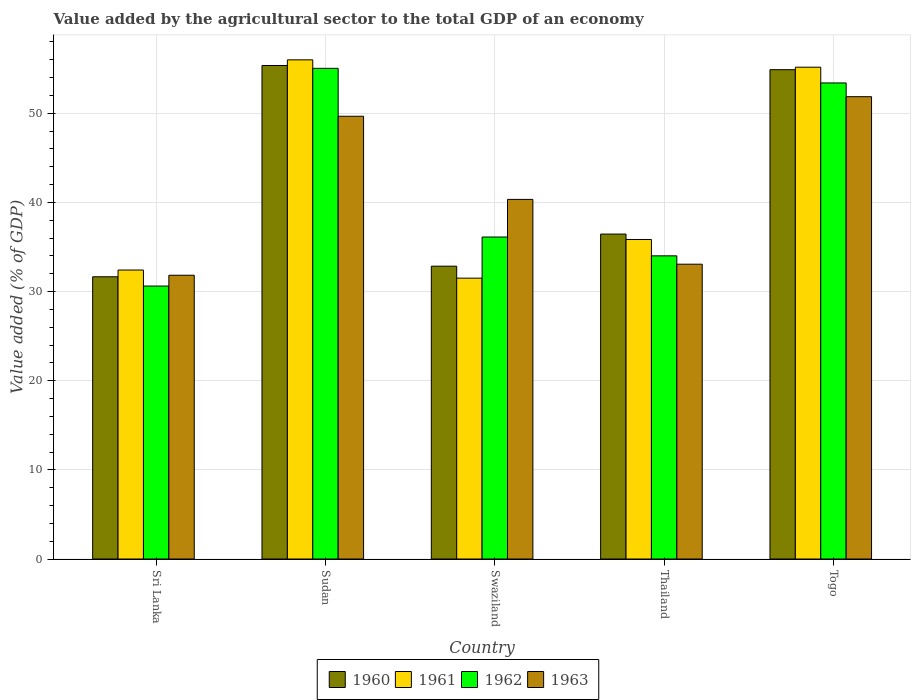How many different coloured bars are there?
Your answer should be compact. 4. Are the number of bars per tick equal to the number of legend labels?
Keep it short and to the point. Yes. How many bars are there on the 5th tick from the left?
Your answer should be compact. 4. What is the label of the 2nd group of bars from the left?
Ensure brevity in your answer.  Sudan. In how many cases, is the number of bars for a given country not equal to the number of legend labels?
Your answer should be very brief. 0. What is the value added by the agricultural sector to the total GDP in 1962 in Sudan?
Your answer should be compact. 55.03. Across all countries, what is the maximum value added by the agricultural sector to the total GDP in 1961?
Give a very brief answer. 55.99. Across all countries, what is the minimum value added by the agricultural sector to the total GDP in 1962?
Offer a terse response. 30.61. In which country was the value added by the agricultural sector to the total GDP in 1960 maximum?
Give a very brief answer. Sudan. In which country was the value added by the agricultural sector to the total GDP in 1960 minimum?
Offer a terse response. Sri Lanka. What is the total value added by the agricultural sector to the total GDP in 1960 in the graph?
Provide a succinct answer. 211.18. What is the difference between the value added by the agricultural sector to the total GDP in 1962 in Swaziland and that in Thailand?
Offer a very short reply. 2.11. What is the difference between the value added by the agricultural sector to the total GDP in 1963 in Swaziland and the value added by the agricultural sector to the total GDP in 1960 in Thailand?
Ensure brevity in your answer.  3.89. What is the average value added by the agricultural sector to the total GDP in 1963 per country?
Provide a succinct answer. 41.35. What is the difference between the value added by the agricultural sector to the total GDP of/in 1961 and value added by the agricultural sector to the total GDP of/in 1963 in Sudan?
Offer a terse response. 6.33. In how many countries, is the value added by the agricultural sector to the total GDP in 1961 greater than 2 %?
Make the answer very short. 5. What is the ratio of the value added by the agricultural sector to the total GDP in 1961 in Swaziland to that in Thailand?
Provide a short and direct response. 0.88. Is the value added by the agricultural sector to the total GDP in 1960 in Thailand less than that in Togo?
Provide a short and direct response. Yes. Is the difference between the value added by the agricultural sector to the total GDP in 1961 in Sri Lanka and Sudan greater than the difference between the value added by the agricultural sector to the total GDP in 1963 in Sri Lanka and Sudan?
Offer a terse response. No. What is the difference between the highest and the second highest value added by the agricultural sector to the total GDP in 1961?
Provide a succinct answer. -19.32. What is the difference between the highest and the lowest value added by the agricultural sector to the total GDP in 1963?
Make the answer very short. 20.03. In how many countries, is the value added by the agricultural sector to the total GDP in 1960 greater than the average value added by the agricultural sector to the total GDP in 1960 taken over all countries?
Your response must be concise. 2. Is the sum of the value added by the agricultural sector to the total GDP in 1961 in Sri Lanka and Swaziland greater than the maximum value added by the agricultural sector to the total GDP in 1960 across all countries?
Your answer should be very brief. Yes. What does the 3rd bar from the right in Sri Lanka represents?
Offer a terse response. 1961. Is it the case that in every country, the sum of the value added by the agricultural sector to the total GDP in 1961 and value added by the agricultural sector to the total GDP in 1960 is greater than the value added by the agricultural sector to the total GDP in 1963?
Keep it short and to the point. Yes. Are all the bars in the graph horizontal?
Give a very brief answer. No. What is the difference between two consecutive major ticks on the Y-axis?
Make the answer very short. 10. Are the values on the major ticks of Y-axis written in scientific E-notation?
Provide a short and direct response. No. Does the graph contain any zero values?
Your answer should be very brief. No. How many legend labels are there?
Offer a terse response. 4. What is the title of the graph?
Give a very brief answer. Value added by the agricultural sector to the total GDP of an economy. Does "1979" appear as one of the legend labels in the graph?
Your response must be concise. No. What is the label or title of the X-axis?
Provide a succinct answer. Country. What is the label or title of the Y-axis?
Your response must be concise. Value added (% of GDP). What is the Value added (% of GDP) in 1960 in Sri Lanka?
Offer a terse response. 31.66. What is the Value added (% of GDP) of 1961 in Sri Lanka?
Offer a very short reply. 32.41. What is the Value added (% of GDP) in 1962 in Sri Lanka?
Give a very brief answer. 30.61. What is the Value added (% of GDP) in 1963 in Sri Lanka?
Give a very brief answer. 31.83. What is the Value added (% of GDP) of 1960 in Sudan?
Provide a succinct answer. 55.35. What is the Value added (% of GDP) in 1961 in Sudan?
Provide a succinct answer. 55.99. What is the Value added (% of GDP) in 1962 in Sudan?
Keep it short and to the point. 55.03. What is the Value added (% of GDP) in 1963 in Sudan?
Offer a terse response. 49.66. What is the Value added (% of GDP) of 1960 in Swaziland?
Your response must be concise. 32.84. What is the Value added (% of GDP) in 1961 in Swaziland?
Keep it short and to the point. 31.5. What is the Value added (% of GDP) of 1962 in Swaziland?
Your response must be concise. 36.11. What is the Value added (% of GDP) of 1963 in Swaziland?
Offer a terse response. 40.33. What is the Value added (% of GDP) in 1960 in Thailand?
Ensure brevity in your answer.  36.44. What is the Value added (% of GDP) in 1961 in Thailand?
Your answer should be compact. 35.84. What is the Value added (% of GDP) of 1962 in Thailand?
Ensure brevity in your answer.  34. What is the Value added (% of GDP) of 1963 in Thailand?
Give a very brief answer. 33.07. What is the Value added (% of GDP) of 1960 in Togo?
Make the answer very short. 54.88. What is the Value added (% of GDP) of 1961 in Togo?
Your answer should be very brief. 55.16. What is the Value added (% of GDP) of 1962 in Togo?
Give a very brief answer. 53.4. What is the Value added (% of GDP) of 1963 in Togo?
Offer a very short reply. 51.85. Across all countries, what is the maximum Value added (% of GDP) in 1960?
Provide a succinct answer. 55.35. Across all countries, what is the maximum Value added (% of GDP) in 1961?
Make the answer very short. 55.99. Across all countries, what is the maximum Value added (% of GDP) in 1962?
Keep it short and to the point. 55.03. Across all countries, what is the maximum Value added (% of GDP) of 1963?
Offer a very short reply. 51.85. Across all countries, what is the minimum Value added (% of GDP) in 1960?
Offer a very short reply. 31.66. Across all countries, what is the minimum Value added (% of GDP) in 1961?
Your response must be concise. 31.5. Across all countries, what is the minimum Value added (% of GDP) in 1962?
Offer a very short reply. 30.61. Across all countries, what is the minimum Value added (% of GDP) of 1963?
Give a very brief answer. 31.83. What is the total Value added (% of GDP) in 1960 in the graph?
Offer a terse response. 211.18. What is the total Value added (% of GDP) of 1961 in the graph?
Your answer should be very brief. 210.9. What is the total Value added (% of GDP) of 1962 in the graph?
Your response must be concise. 209.16. What is the total Value added (% of GDP) of 1963 in the graph?
Ensure brevity in your answer.  206.74. What is the difference between the Value added (% of GDP) in 1960 in Sri Lanka and that in Sudan?
Your answer should be very brief. -23.7. What is the difference between the Value added (% of GDP) of 1961 in Sri Lanka and that in Sudan?
Give a very brief answer. -23.58. What is the difference between the Value added (% of GDP) of 1962 in Sri Lanka and that in Sudan?
Keep it short and to the point. -24.42. What is the difference between the Value added (% of GDP) in 1963 in Sri Lanka and that in Sudan?
Your answer should be very brief. -17.83. What is the difference between the Value added (% of GDP) in 1960 in Sri Lanka and that in Swaziland?
Offer a terse response. -1.19. What is the difference between the Value added (% of GDP) of 1961 in Sri Lanka and that in Swaziland?
Your answer should be very brief. 0.91. What is the difference between the Value added (% of GDP) in 1962 in Sri Lanka and that in Swaziland?
Offer a terse response. -5.5. What is the difference between the Value added (% of GDP) of 1963 in Sri Lanka and that in Swaziland?
Your answer should be very brief. -8.51. What is the difference between the Value added (% of GDP) in 1960 in Sri Lanka and that in Thailand?
Your response must be concise. -4.79. What is the difference between the Value added (% of GDP) in 1961 in Sri Lanka and that in Thailand?
Provide a short and direct response. -3.43. What is the difference between the Value added (% of GDP) in 1962 in Sri Lanka and that in Thailand?
Your answer should be very brief. -3.39. What is the difference between the Value added (% of GDP) in 1963 in Sri Lanka and that in Thailand?
Ensure brevity in your answer.  -1.24. What is the difference between the Value added (% of GDP) in 1960 in Sri Lanka and that in Togo?
Offer a very short reply. -23.23. What is the difference between the Value added (% of GDP) in 1961 in Sri Lanka and that in Togo?
Your answer should be very brief. -22.75. What is the difference between the Value added (% of GDP) in 1962 in Sri Lanka and that in Togo?
Ensure brevity in your answer.  -22.78. What is the difference between the Value added (% of GDP) in 1963 in Sri Lanka and that in Togo?
Provide a short and direct response. -20.03. What is the difference between the Value added (% of GDP) in 1960 in Sudan and that in Swaziland?
Keep it short and to the point. 22.51. What is the difference between the Value added (% of GDP) of 1961 in Sudan and that in Swaziland?
Ensure brevity in your answer.  24.49. What is the difference between the Value added (% of GDP) of 1962 in Sudan and that in Swaziland?
Offer a very short reply. 18.92. What is the difference between the Value added (% of GDP) of 1963 in Sudan and that in Swaziland?
Ensure brevity in your answer.  9.32. What is the difference between the Value added (% of GDP) of 1960 in Sudan and that in Thailand?
Your answer should be very brief. 18.91. What is the difference between the Value added (% of GDP) in 1961 in Sudan and that in Thailand?
Keep it short and to the point. 20.15. What is the difference between the Value added (% of GDP) in 1962 in Sudan and that in Thailand?
Keep it short and to the point. 21.03. What is the difference between the Value added (% of GDP) in 1963 in Sudan and that in Thailand?
Your answer should be very brief. 16.59. What is the difference between the Value added (% of GDP) in 1960 in Sudan and that in Togo?
Provide a succinct answer. 0.47. What is the difference between the Value added (% of GDP) of 1961 in Sudan and that in Togo?
Offer a terse response. 0.83. What is the difference between the Value added (% of GDP) in 1962 in Sudan and that in Togo?
Offer a very short reply. 1.64. What is the difference between the Value added (% of GDP) in 1963 in Sudan and that in Togo?
Keep it short and to the point. -2.19. What is the difference between the Value added (% of GDP) of 1960 in Swaziland and that in Thailand?
Provide a short and direct response. -3.6. What is the difference between the Value added (% of GDP) in 1961 in Swaziland and that in Thailand?
Your answer should be very brief. -4.34. What is the difference between the Value added (% of GDP) of 1962 in Swaziland and that in Thailand?
Keep it short and to the point. 2.11. What is the difference between the Value added (% of GDP) in 1963 in Swaziland and that in Thailand?
Give a very brief answer. 7.27. What is the difference between the Value added (% of GDP) of 1960 in Swaziland and that in Togo?
Keep it short and to the point. -22.04. What is the difference between the Value added (% of GDP) of 1961 in Swaziland and that in Togo?
Keep it short and to the point. -23.66. What is the difference between the Value added (% of GDP) of 1962 in Swaziland and that in Togo?
Your response must be concise. -17.28. What is the difference between the Value added (% of GDP) in 1963 in Swaziland and that in Togo?
Give a very brief answer. -11.52. What is the difference between the Value added (% of GDP) of 1960 in Thailand and that in Togo?
Provide a short and direct response. -18.44. What is the difference between the Value added (% of GDP) in 1961 in Thailand and that in Togo?
Provide a succinct answer. -19.32. What is the difference between the Value added (% of GDP) of 1962 in Thailand and that in Togo?
Your answer should be very brief. -19.39. What is the difference between the Value added (% of GDP) in 1963 in Thailand and that in Togo?
Provide a succinct answer. -18.79. What is the difference between the Value added (% of GDP) of 1960 in Sri Lanka and the Value added (% of GDP) of 1961 in Sudan?
Keep it short and to the point. -24.33. What is the difference between the Value added (% of GDP) of 1960 in Sri Lanka and the Value added (% of GDP) of 1962 in Sudan?
Offer a terse response. -23.38. What is the difference between the Value added (% of GDP) in 1960 in Sri Lanka and the Value added (% of GDP) in 1963 in Sudan?
Make the answer very short. -18. What is the difference between the Value added (% of GDP) in 1961 in Sri Lanka and the Value added (% of GDP) in 1962 in Sudan?
Give a very brief answer. -22.62. What is the difference between the Value added (% of GDP) of 1961 in Sri Lanka and the Value added (% of GDP) of 1963 in Sudan?
Your response must be concise. -17.25. What is the difference between the Value added (% of GDP) in 1962 in Sri Lanka and the Value added (% of GDP) in 1963 in Sudan?
Give a very brief answer. -19.04. What is the difference between the Value added (% of GDP) of 1960 in Sri Lanka and the Value added (% of GDP) of 1961 in Swaziland?
Your answer should be compact. 0.16. What is the difference between the Value added (% of GDP) in 1960 in Sri Lanka and the Value added (% of GDP) in 1962 in Swaziland?
Offer a very short reply. -4.46. What is the difference between the Value added (% of GDP) of 1960 in Sri Lanka and the Value added (% of GDP) of 1963 in Swaziland?
Make the answer very short. -8.68. What is the difference between the Value added (% of GDP) of 1961 in Sri Lanka and the Value added (% of GDP) of 1962 in Swaziland?
Offer a very short reply. -3.7. What is the difference between the Value added (% of GDP) of 1961 in Sri Lanka and the Value added (% of GDP) of 1963 in Swaziland?
Keep it short and to the point. -7.92. What is the difference between the Value added (% of GDP) of 1962 in Sri Lanka and the Value added (% of GDP) of 1963 in Swaziland?
Offer a very short reply. -9.72. What is the difference between the Value added (% of GDP) in 1960 in Sri Lanka and the Value added (% of GDP) in 1961 in Thailand?
Give a very brief answer. -4.18. What is the difference between the Value added (% of GDP) in 1960 in Sri Lanka and the Value added (% of GDP) in 1962 in Thailand?
Offer a terse response. -2.35. What is the difference between the Value added (% of GDP) in 1960 in Sri Lanka and the Value added (% of GDP) in 1963 in Thailand?
Provide a short and direct response. -1.41. What is the difference between the Value added (% of GDP) in 1961 in Sri Lanka and the Value added (% of GDP) in 1962 in Thailand?
Offer a terse response. -1.59. What is the difference between the Value added (% of GDP) of 1961 in Sri Lanka and the Value added (% of GDP) of 1963 in Thailand?
Provide a succinct answer. -0.65. What is the difference between the Value added (% of GDP) of 1962 in Sri Lanka and the Value added (% of GDP) of 1963 in Thailand?
Ensure brevity in your answer.  -2.45. What is the difference between the Value added (% of GDP) of 1960 in Sri Lanka and the Value added (% of GDP) of 1961 in Togo?
Provide a short and direct response. -23.51. What is the difference between the Value added (% of GDP) of 1960 in Sri Lanka and the Value added (% of GDP) of 1962 in Togo?
Your answer should be compact. -21.74. What is the difference between the Value added (% of GDP) of 1960 in Sri Lanka and the Value added (% of GDP) of 1963 in Togo?
Your answer should be very brief. -20.2. What is the difference between the Value added (% of GDP) in 1961 in Sri Lanka and the Value added (% of GDP) in 1962 in Togo?
Give a very brief answer. -20.98. What is the difference between the Value added (% of GDP) in 1961 in Sri Lanka and the Value added (% of GDP) in 1963 in Togo?
Ensure brevity in your answer.  -19.44. What is the difference between the Value added (% of GDP) in 1962 in Sri Lanka and the Value added (% of GDP) in 1963 in Togo?
Your response must be concise. -21.24. What is the difference between the Value added (% of GDP) in 1960 in Sudan and the Value added (% of GDP) in 1961 in Swaziland?
Ensure brevity in your answer.  23.85. What is the difference between the Value added (% of GDP) in 1960 in Sudan and the Value added (% of GDP) in 1962 in Swaziland?
Your response must be concise. 19.24. What is the difference between the Value added (% of GDP) of 1960 in Sudan and the Value added (% of GDP) of 1963 in Swaziland?
Provide a succinct answer. 15.02. What is the difference between the Value added (% of GDP) in 1961 in Sudan and the Value added (% of GDP) in 1962 in Swaziland?
Offer a terse response. 19.87. What is the difference between the Value added (% of GDP) in 1961 in Sudan and the Value added (% of GDP) in 1963 in Swaziland?
Give a very brief answer. 15.65. What is the difference between the Value added (% of GDP) in 1962 in Sudan and the Value added (% of GDP) in 1963 in Swaziland?
Your response must be concise. 14.7. What is the difference between the Value added (% of GDP) in 1960 in Sudan and the Value added (% of GDP) in 1961 in Thailand?
Your response must be concise. 19.51. What is the difference between the Value added (% of GDP) in 1960 in Sudan and the Value added (% of GDP) in 1962 in Thailand?
Your answer should be compact. 21.35. What is the difference between the Value added (% of GDP) in 1960 in Sudan and the Value added (% of GDP) in 1963 in Thailand?
Provide a short and direct response. 22.29. What is the difference between the Value added (% of GDP) of 1961 in Sudan and the Value added (% of GDP) of 1962 in Thailand?
Ensure brevity in your answer.  21.98. What is the difference between the Value added (% of GDP) in 1961 in Sudan and the Value added (% of GDP) in 1963 in Thailand?
Offer a terse response. 22.92. What is the difference between the Value added (% of GDP) in 1962 in Sudan and the Value added (% of GDP) in 1963 in Thailand?
Make the answer very short. 21.97. What is the difference between the Value added (% of GDP) in 1960 in Sudan and the Value added (% of GDP) in 1961 in Togo?
Give a very brief answer. 0.19. What is the difference between the Value added (% of GDP) of 1960 in Sudan and the Value added (% of GDP) of 1962 in Togo?
Make the answer very short. 1.96. What is the difference between the Value added (% of GDP) of 1960 in Sudan and the Value added (% of GDP) of 1963 in Togo?
Keep it short and to the point. 3.5. What is the difference between the Value added (% of GDP) of 1961 in Sudan and the Value added (% of GDP) of 1962 in Togo?
Your response must be concise. 2.59. What is the difference between the Value added (% of GDP) in 1961 in Sudan and the Value added (% of GDP) in 1963 in Togo?
Keep it short and to the point. 4.13. What is the difference between the Value added (% of GDP) of 1962 in Sudan and the Value added (% of GDP) of 1963 in Togo?
Your answer should be very brief. 3.18. What is the difference between the Value added (% of GDP) of 1960 in Swaziland and the Value added (% of GDP) of 1961 in Thailand?
Keep it short and to the point. -2.99. What is the difference between the Value added (% of GDP) in 1960 in Swaziland and the Value added (% of GDP) in 1962 in Thailand?
Offer a terse response. -1.16. What is the difference between the Value added (% of GDP) in 1960 in Swaziland and the Value added (% of GDP) in 1963 in Thailand?
Offer a terse response. -0.22. What is the difference between the Value added (% of GDP) of 1961 in Swaziland and the Value added (% of GDP) of 1962 in Thailand?
Your answer should be very brief. -2.5. What is the difference between the Value added (% of GDP) in 1961 in Swaziland and the Value added (% of GDP) in 1963 in Thailand?
Keep it short and to the point. -1.57. What is the difference between the Value added (% of GDP) in 1962 in Swaziland and the Value added (% of GDP) in 1963 in Thailand?
Your answer should be compact. 3.05. What is the difference between the Value added (% of GDP) in 1960 in Swaziland and the Value added (% of GDP) in 1961 in Togo?
Offer a very short reply. -22.32. What is the difference between the Value added (% of GDP) in 1960 in Swaziland and the Value added (% of GDP) in 1962 in Togo?
Offer a terse response. -20.55. What is the difference between the Value added (% of GDP) in 1960 in Swaziland and the Value added (% of GDP) in 1963 in Togo?
Offer a terse response. -19.01. What is the difference between the Value added (% of GDP) of 1961 in Swaziland and the Value added (% of GDP) of 1962 in Togo?
Your answer should be compact. -21.9. What is the difference between the Value added (% of GDP) in 1961 in Swaziland and the Value added (% of GDP) in 1963 in Togo?
Make the answer very short. -20.35. What is the difference between the Value added (% of GDP) in 1962 in Swaziland and the Value added (% of GDP) in 1963 in Togo?
Offer a terse response. -15.74. What is the difference between the Value added (% of GDP) in 1960 in Thailand and the Value added (% of GDP) in 1961 in Togo?
Provide a succinct answer. -18.72. What is the difference between the Value added (% of GDP) of 1960 in Thailand and the Value added (% of GDP) of 1962 in Togo?
Your response must be concise. -16.95. What is the difference between the Value added (% of GDP) in 1960 in Thailand and the Value added (% of GDP) in 1963 in Togo?
Make the answer very short. -15.41. What is the difference between the Value added (% of GDP) in 1961 in Thailand and the Value added (% of GDP) in 1962 in Togo?
Your answer should be compact. -17.56. What is the difference between the Value added (% of GDP) of 1961 in Thailand and the Value added (% of GDP) of 1963 in Togo?
Your response must be concise. -16.01. What is the difference between the Value added (% of GDP) of 1962 in Thailand and the Value added (% of GDP) of 1963 in Togo?
Your response must be concise. -17.85. What is the average Value added (% of GDP) of 1960 per country?
Give a very brief answer. 42.24. What is the average Value added (% of GDP) in 1961 per country?
Give a very brief answer. 42.18. What is the average Value added (% of GDP) of 1962 per country?
Make the answer very short. 41.83. What is the average Value added (% of GDP) of 1963 per country?
Your answer should be compact. 41.35. What is the difference between the Value added (% of GDP) in 1960 and Value added (% of GDP) in 1961 in Sri Lanka?
Make the answer very short. -0.76. What is the difference between the Value added (% of GDP) of 1960 and Value added (% of GDP) of 1962 in Sri Lanka?
Your answer should be compact. 1.04. What is the difference between the Value added (% of GDP) of 1960 and Value added (% of GDP) of 1963 in Sri Lanka?
Make the answer very short. -0.17. What is the difference between the Value added (% of GDP) in 1961 and Value added (% of GDP) in 1962 in Sri Lanka?
Your answer should be compact. 1.8. What is the difference between the Value added (% of GDP) in 1961 and Value added (% of GDP) in 1963 in Sri Lanka?
Provide a short and direct response. 0.59. What is the difference between the Value added (% of GDP) in 1962 and Value added (% of GDP) in 1963 in Sri Lanka?
Ensure brevity in your answer.  -1.21. What is the difference between the Value added (% of GDP) of 1960 and Value added (% of GDP) of 1961 in Sudan?
Give a very brief answer. -0.64. What is the difference between the Value added (% of GDP) of 1960 and Value added (% of GDP) of 1962 in Sudan?
Provide a succinct answer. 0.32. What is the difference between the Value added (% of GDP) in 1960 and Value added (% of GDP) in 1963 in Sudan?
Provide a succinct answer. 5.69. What is the difference between the Value added (% of GDP) of 1961 and Value added (% of GDP) of 1962 in Sudan?
Your response must be concise. 0.95. What is the difference between the Value added (% of GDP) of 1961 and Value added (% of GDP) of 1963 in Sudan?
Your answer should be compact. 6.33. What is the difference between the Value added (% of GDP) in 1962 and Value added (% of GDP) in 1963 in Sudan?
Keep it short and to the point. 5.37. What is the difference between the Value added (% of GDP) in 1960 and Value added (% of GDP) in 1961 in Swaziland?
Keep it short and to the point. 1.35. What is the difference between the Value added (% of GDP) of 1960 and Value added (% of GDP) of 1962 in Swaziland?
Give a very brief answer. -3.27. What is the difference between the Value added (% of GDP) in 1960 and Value added (% of GDP) in 1963 in Swaziland?
Your answer should be very brief. -7.49. What is the difference between the Value added (% of GDP) of 1961 and Value added (% of GDP) of 1962 in Swaziland?
Your answer should be compact. -4.61. What is the difference between the Value added (% of GDP) in 1961 and Value added (% of GDP) in 1963 in Swaziland?
Provide a short and direct response. -8.83. What is the difference between the Value added (% of GDP) in 1962 and Value added (% of GDP) in 1963 in Swaziland?
Your answer should be compact. -4.22. What is the difference between the Value added (% of GDP) of 1960 and Value added (% of GDP) of 1961 in Thailand?
Make the answer very short. 0.61. What is the difference between the Value added (% of GDP) of 1960 and Value added (% of GDP) of 1962 in Thailand?
Give a very brief answer. 2.44. What is the difference between the Value added (% of GDP) in 1960 and Value added (% of GDP) in 1963 in Thailand?
Provide a succinct answer. 3.38. What is the difference between the Value added (% of GDP) of 1961 and Value added (% of GDP) of 1962 in Thailand?
Provide a short and direct response. 1.84. What is the difference between the Value added (% of GDP) of 1961 and Value added (% of GDP) of 1963 in Thailand?
Ensure brevity in your answer.  2.77. What is the difference between the Value added (% of GDP) of 1962 and Value added (% of GDP) of 1963 in Thailand?
Your answer should be compact. 0.94. What is the difference between the Value added (% of GDP) of 1960 and Value added (% of GDP) of 1961 in Togo?
Your response must be concise. -0.28. What is the difference between the Value added (% of GDP) of 1960 and Value added (% of GDP) of 1962 in Togo?
Your response must be concise. 1.49. What is the difference between the Value added (% of GDP) in 1960 and Value added (% of GDP) in 1963 in Togo?
Offer a very short reply. 3.03. What is the difference between the Value added (% of GDP) of 1961 and Value added (% of GDP) of 1962 in Togo?
Keep it short and to the point. 1.77. What is the difference between the Value added (% of GDP) of 1961 and Value added (% of GDP) of 1963 in Togo?
Your answer should be compact. 3.31. What is the difference between the Value added (% of GDP) in 1962 and Value added (% of GDP) in 1963 in Togo?
Offer a terse response. 1.54. What is the ratio of the Value added (% of GDP) in 1960 in Sri Lanka to that in Sudan?
Keep it short and to the point. 0.57. What is the ratio of the Value added (% of GDP) in 1961 in Sri Lanka to that in Sudan?
Offer a very short reply. 0.58. What is the ratio of the Value added (% of GDP) of 1962 in Sri Lanka to that in Sudan?
Provide a succinct answer. 0.56. What is the ratio of the Value added (% of GDP) of 1963 in Sri Lanka to that in Sudan?
Your response must be concise. 0.64. What is the ratio of the Value added (% of GDP) in 1960 in Sri Lanka to that in Swaziland?
Give a very brief answer. 0.96. What is the ratio of the Value added (% of GDP) in 1961 in Sri Lanka to that in Swaziland?
Your response must be concise. 1.03. What is the ratio of the Value added (% of GDP) in 1962 in Sri Lanka to that in Swaziland?
Offer a very short reply. 0.85. What is the ratio of the Value added (% of GDP) of 1963 in Sri Lanka to that in Swaziland?
Your answer should be compact. 0.79. What is the ratio of the Value added (% of GDP) of 1960 in Sri Lanka to that in Thailand?
Give a very brief answer. 0.87. What is the ratio of the Value added (% of GDP) in 1961 in Sri Lanka to that in Thailand?
Your response must be concise. 0.9. What is the ratio of the Value added (% of GDP) in 1962 in Sri Lanka to that in Thailand?
Your response must be concise. 0.9. What is the ratio of the Value added (% of GDP) of 1963 in Sri Lanka to that in Thailand?
Make the answer very short. 0.96. What is the ratio of the Value added (% of GDP) of 1960 in Sri Lanka to that in Togo?
Keep it short and to the point. 0.58. What is the ratio of the Value added (% of GDP) of 1961 in Sri Lanka to that in Togo?
Offer a very short reply. 0.59. What is the ratio of the Value added (% of GDP) of 1962 in Sri Lanka to that in Togo?
Your answer should be compact. 0.57. What is the ratio of the Value added (% of GDP) in 1963 in Sri Lanka to that in Togo?
Provide a succinct answer. 0.61. What is the ratio of the Value added (% of GDP) in 1960 in Sudan to that in Swaziland?
Provide a short and direct response. 1.69. What is the ratio of the Value added (% of GDP) in 1961 in Sudan to that in Swaziland?
Give a very brief answer. 1.78. What is the ratio of the Value added (% of GDP) in 1962 in Sudan to that in Swaziland?
Your answer should be compact. 1.52. What is the ratio of the Value added (% of GDP) of 1963 in Sudan to that in Swaziland?
Give a very brief answer. 1.23. What is the ratio of the Value added (% of GDP) in 1960 in Sudan to that in Thailand?
Give a very brief answer. 1.52. What is the ratio of the Value added (% of GDP) in 1961 in Sudan to that in Thailand?
Make the answer very short. 1.56. What is the ratio of the Value added (% of GDP) in 1962 in Sudan to that in Thailand?
Make the answer very short. 1.62. What is the ratio of the Value added (% of GDP) of 1963 in Sudan to that in Thailand?
Keep it short and to the point. 1.5. What is the ratio of the Value added (% of GDP) of 1960 in Sudan to that in Togo?
Your answer should be compact. 1.01. What is the ratio of the Value added (% of GDP) in 1962 in Sudan to that in Togo?
Provide a succinct answer. 1.03. What is the ratio of the Value added (% of GDP) of 1963 in Sudan to that in Togo?
Provide a short and direct response. 0.96. What is the ratio of the Value added (% of GDP) of 1960 in Swaziland to that in Thailand?
Provide a short and direct response. 0.9. What is the ratio of the Value added (% of GDP) in 1961 in Swaziland to that in Thailand?
Offer a very short reply. 0.88. What is the ratio of the Value added (% of GDP) of 1962 in Swaziland to that in Thailand?
Provide a succinct answer. 1.06. What is the ratio of the Value added (% of GDP) of 1963 in Swaziland to that in Thailand?
Your response must be concise. 1.22. What is the ratio of the Value added (% of GDP) of 1960 in Swaziland to that in Togo?
Provide a short and direct response. 0.6. What is the ratio of the Value added (% of GDP) of 1961 in Swaziland to that in Togo?
Your response must be concise. 0.57. What is the ratio of the Value added (% of GDP) of 1962 in Swaziland to that in Togo?
Your answer should be very brief. 0.68. What is the ratio of the Value added (% of GDP) of 1963 in Swaziland to that in Togo?
Offer a terse response. 0.78. What is the ratio of the Value added (% of GDP) in 1960 in Thailand to that in Togo?
Give a very brief answer. 0.66. What is the ratio of the Value added (% of GDP) in 1961 in Thailand to that in Togo?
Your answer should be compact. 0.65. What is the ratio of the Value added (% of GDP) in 1962 in Thailand to that in Togo?
Make the answer very short. 0.64. What is the ratio of the Value added (% of GDP) in 1963 in Thailand to that in Togo?
Your response must be concise. 0.64. What is the difference between the highest and the second highest Value added (% of GDP) of 1960?
Give a very brief answer. 0.47. What is the difference between the highest and the second highest Value added (% of GDP) of 1961?
Your answer should be very brief. 0.83. What is the difference between the highest and the second highest Value added (% of GDP) of 1962?
Provide a short and direct response. 1.64. What is the difference between the highest and the second highest Value added (% of GDP) in 1963?
Your response must be concise. 2.19. What is the difference between the highest and the lowest Value added (% of GDP) of 1960?
Your response must be concise. 23.7. What is the difference between the highest and the lowest Value added (% of GDP) in 1961?
Your answer should be compact. 24.49. What is the difference between the highest and the lowest Value added (% of GDP) in 1962?
Make the answer very short. 24.42. What is the difference between the highest and the lowest Value added (% of GDP) in 1963?
Provide a short and direct response. 20.03. 